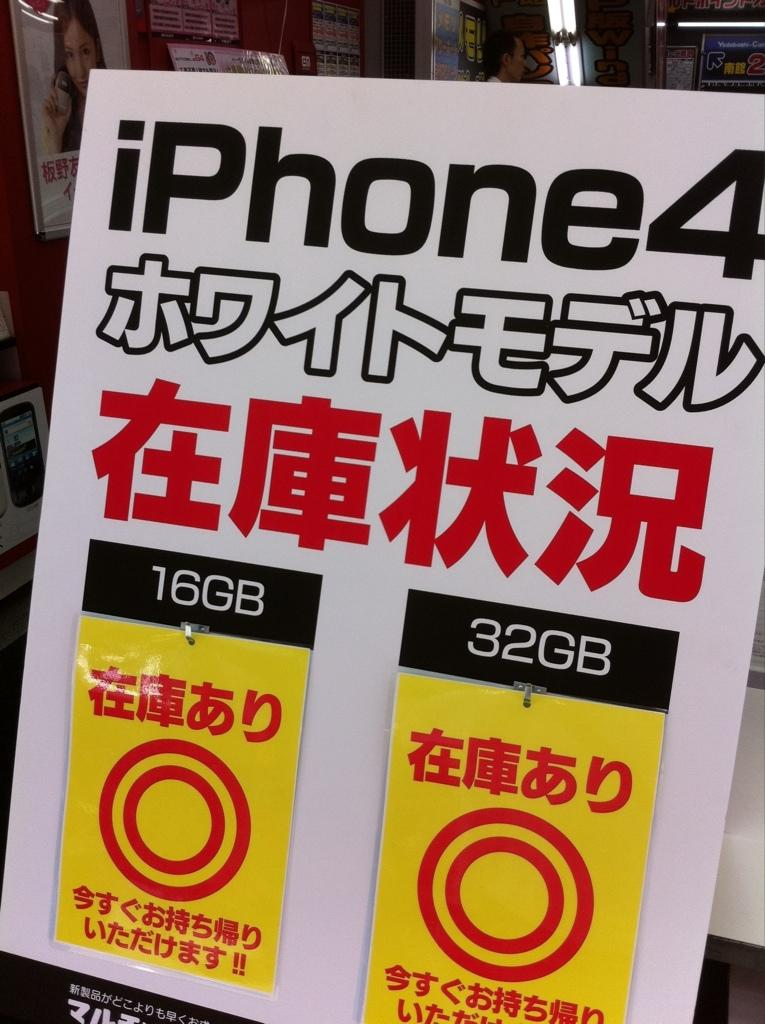Provide a one-sentence caption for the provided image. A poster advertisement for the iphone 4 in written English and Chinese. 